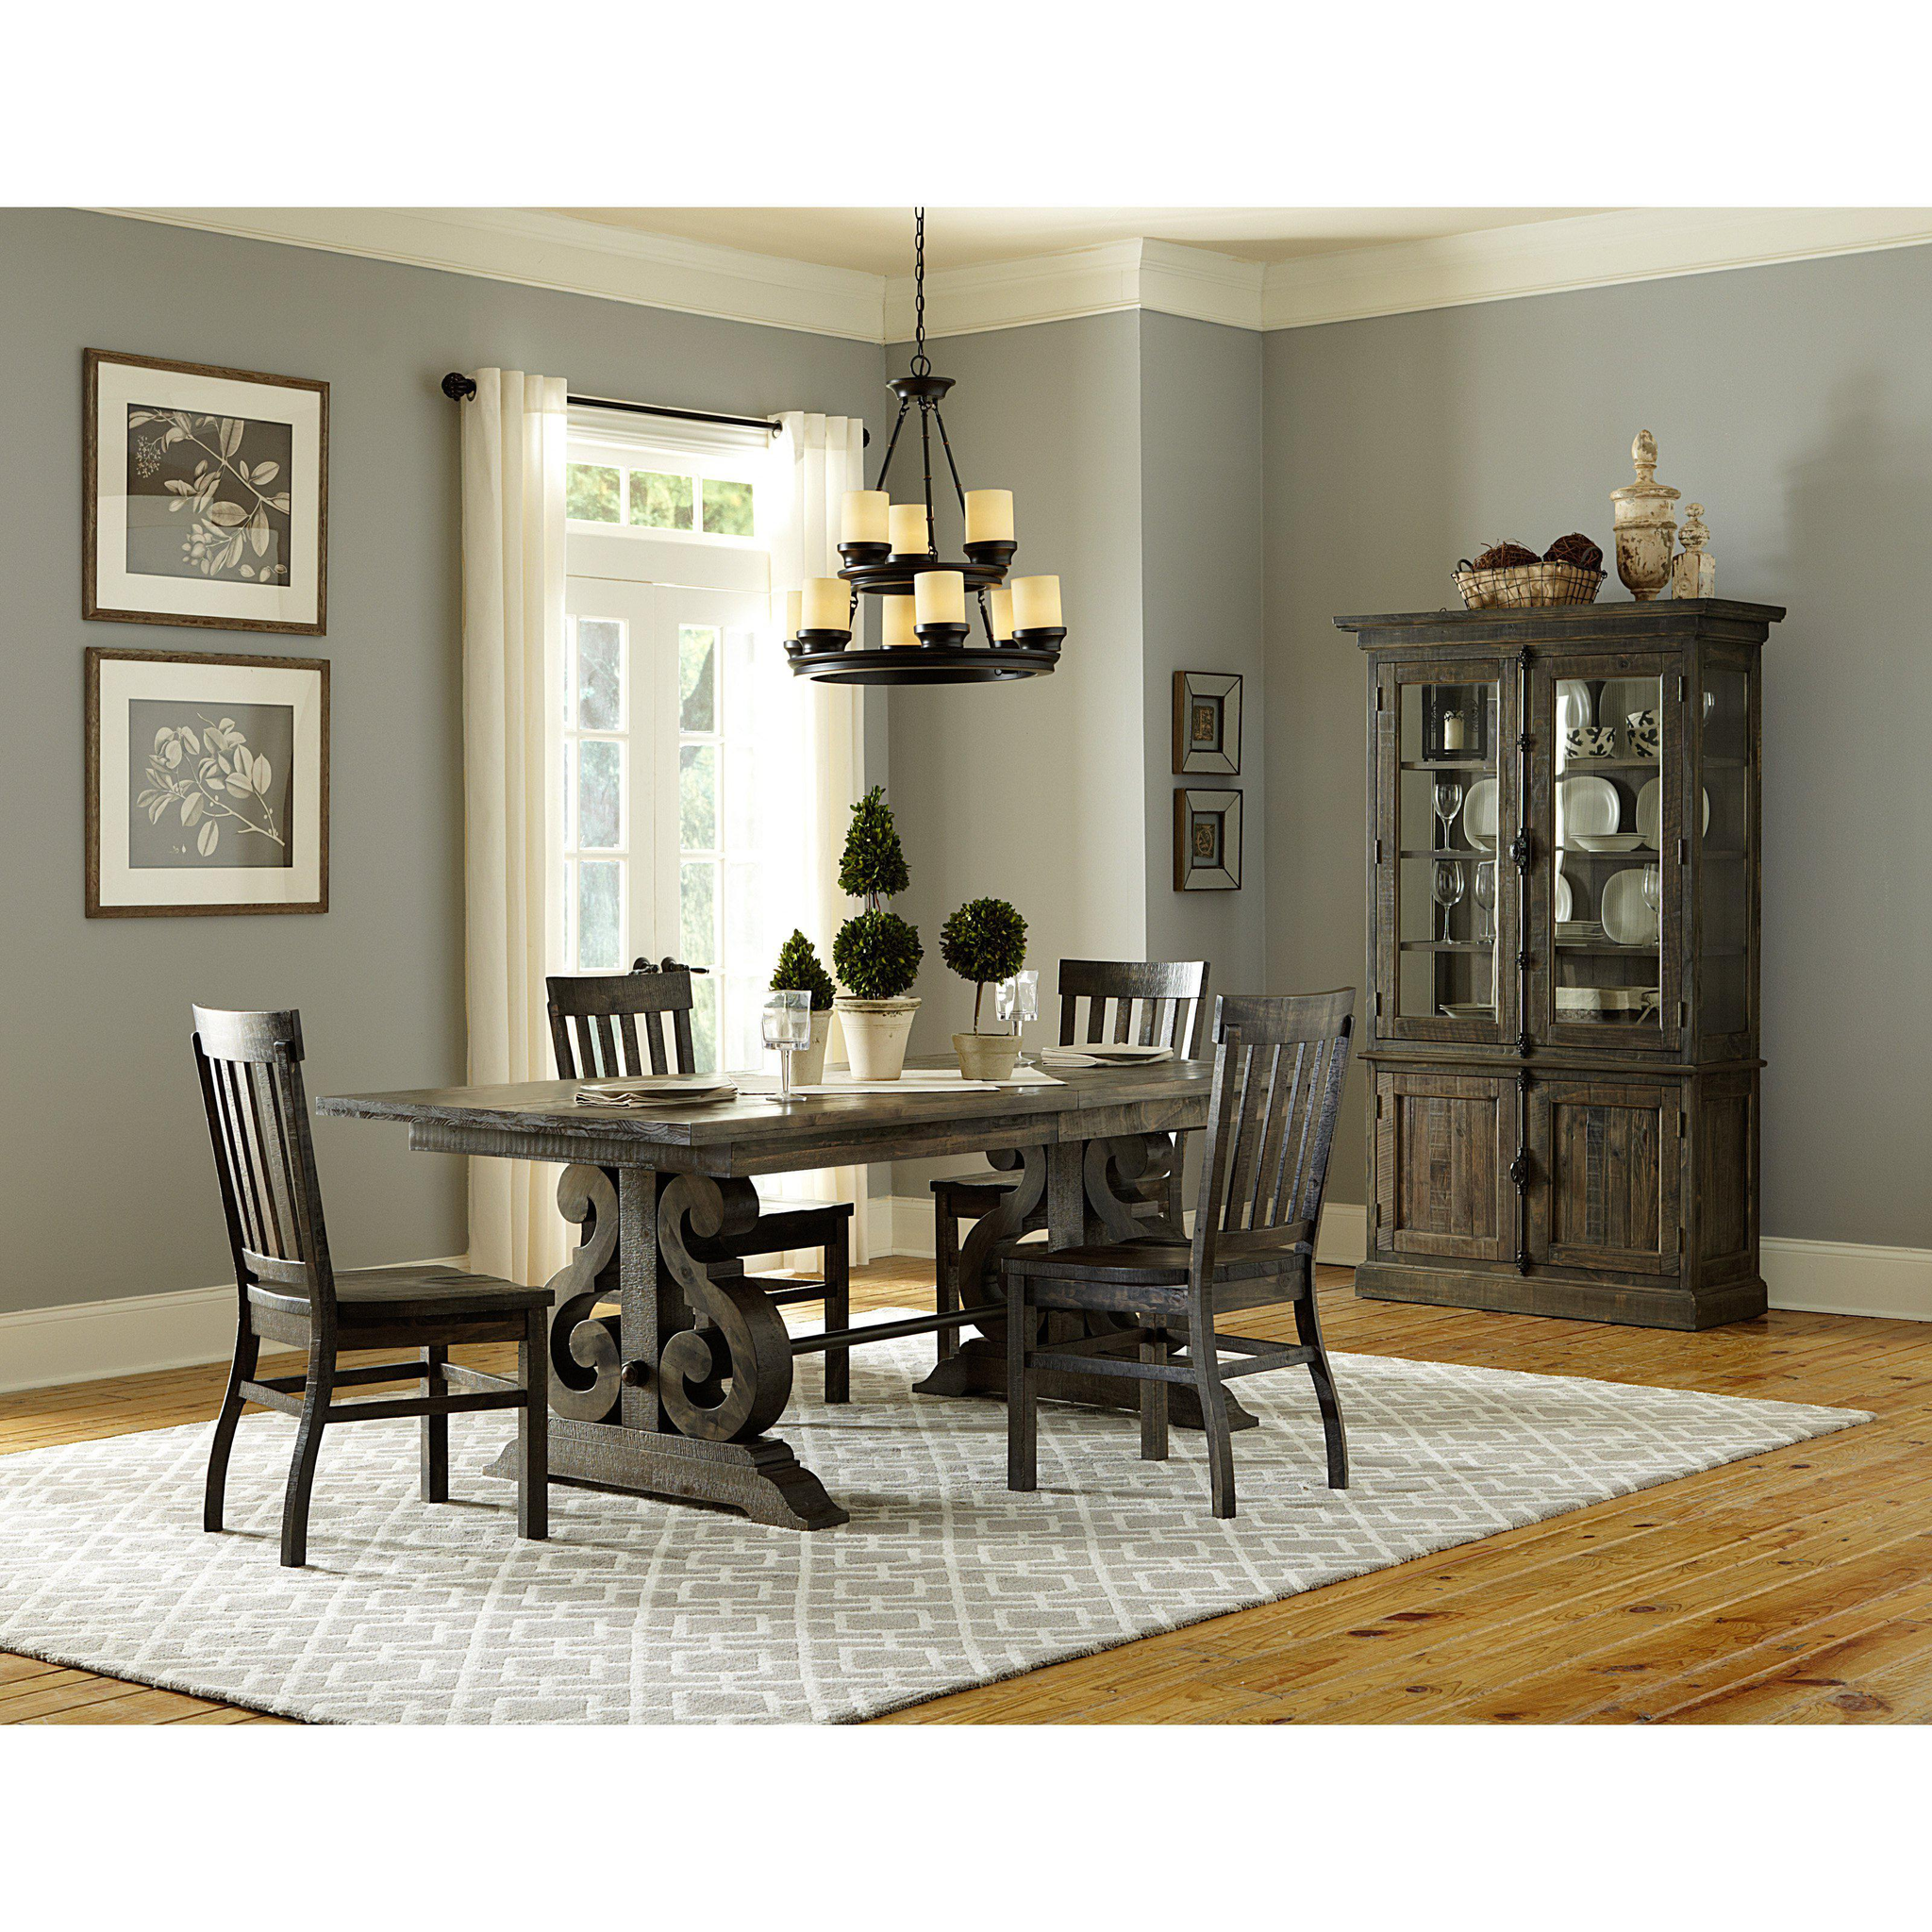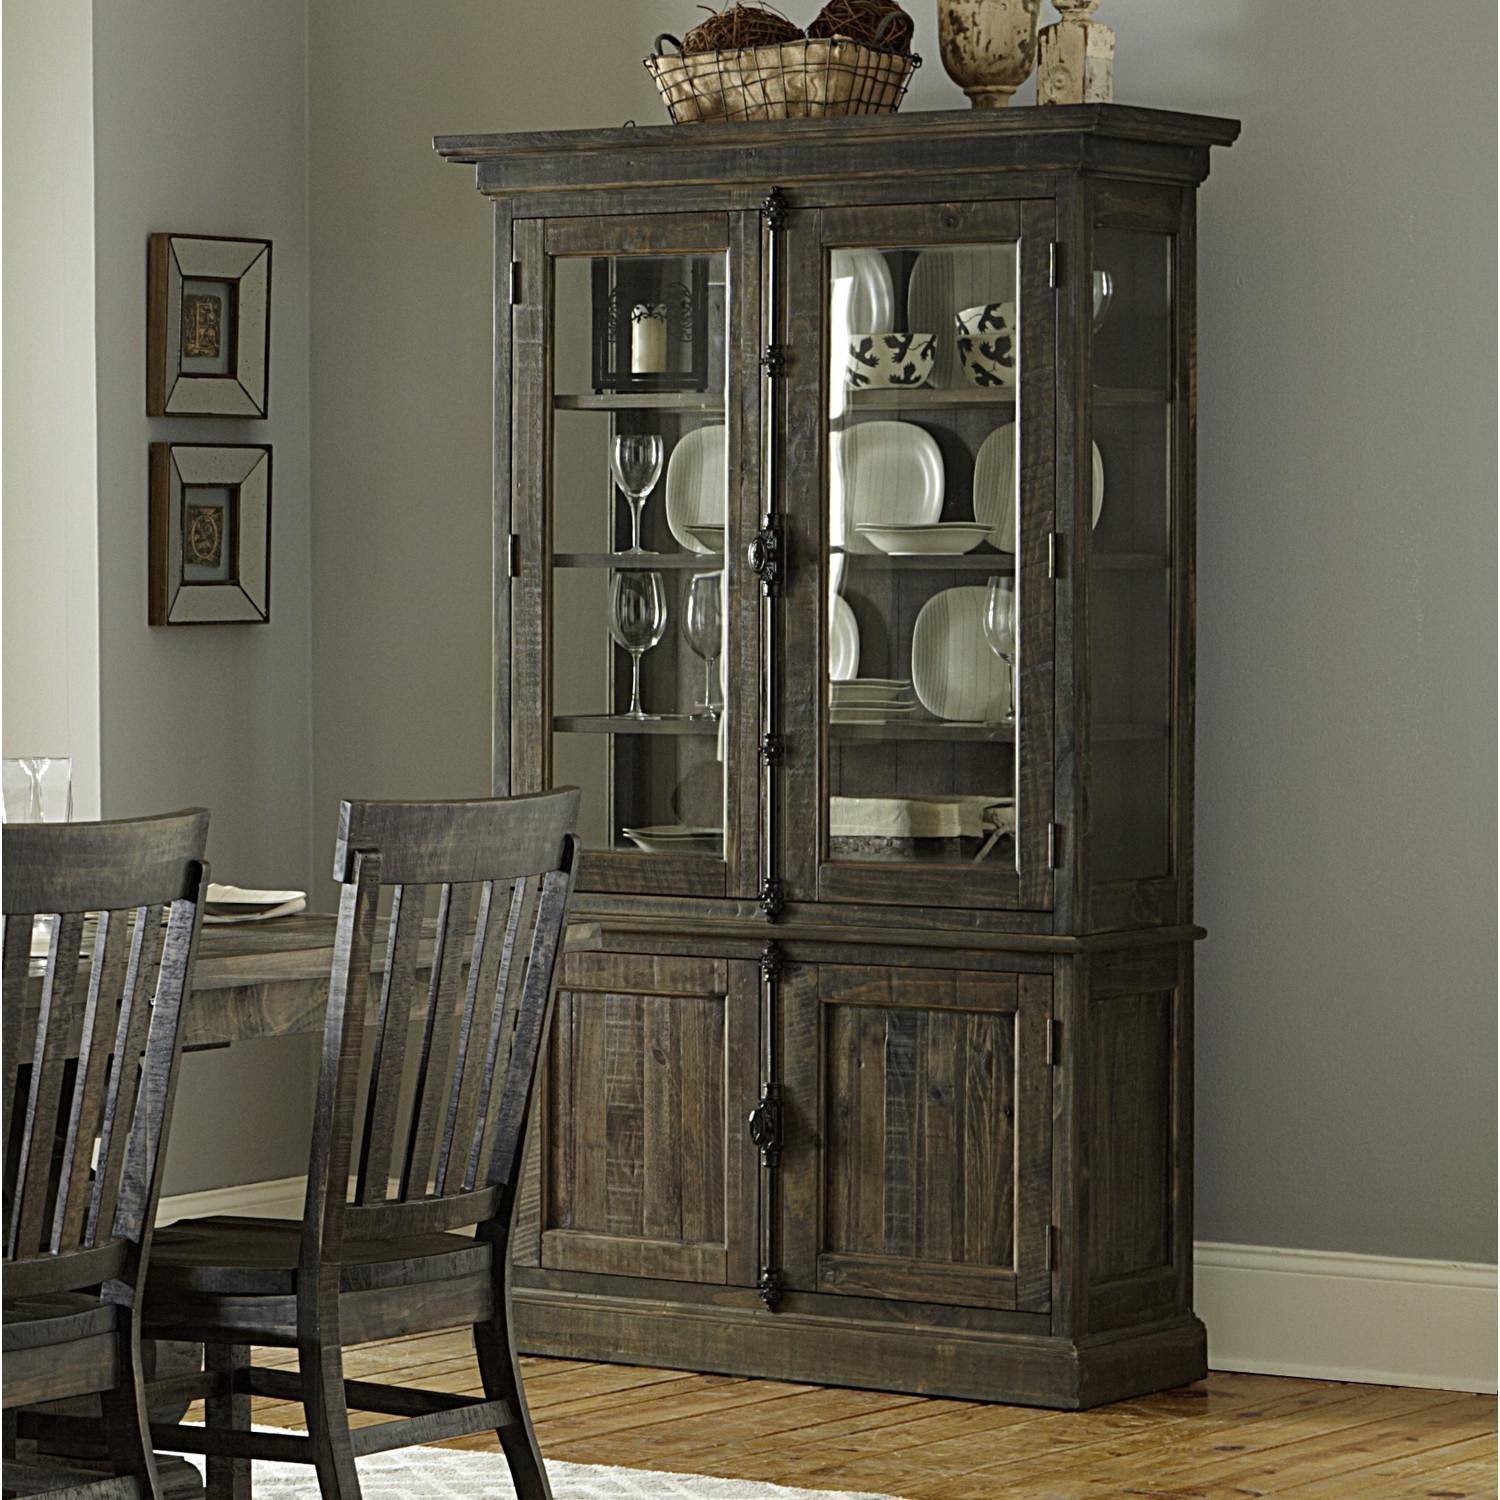The first image is the image on the left, the second image is the image on the right. For the images shown, is this caption "There is basket of dark objects atop the china cabinet in the image on the right." true? Answer yes or no. Yes. The first image is the image on the left, the second image is the image on the right. Examine the images to the left and right. Is the description "There is a combined total of three chairs between the two images." accurate? Answer yes or no. No. 